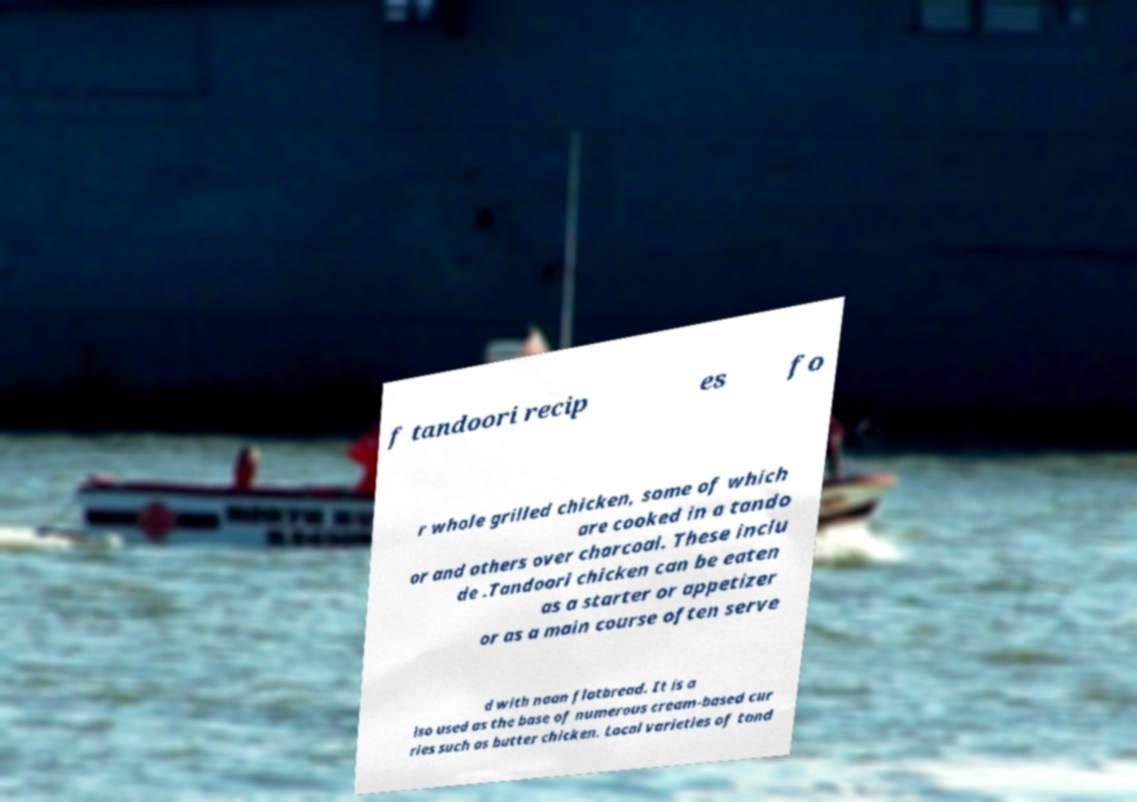There's text embedded in this image that I need extracted. Can you transcribe it verbatim? f tandoori recip es fo r whole grilled chicken, some of which are cooked in a tando or and others over charcoal. These inclu de .Tandoori chicken can be eaten as a starter or appetizer or as a main course often serve d with naan flatbread. It is a lso used as the base of numerous cream-based cur ries such as butter chicken. Local varieties of tand 